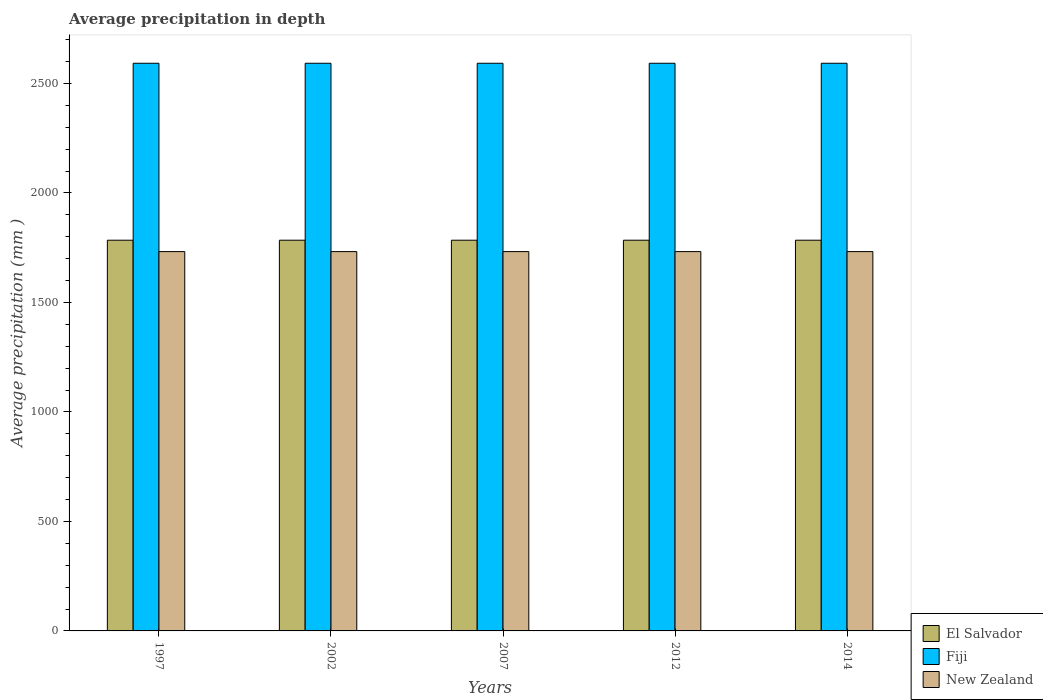How many different coloured bars are there?
Keep it short and to the point. 3. How many groups of bars are there?
Offer a terse response. 5. Are the number of bars per tick equal to the number of legend labels?
Your response must be concise. Yes. In how many cases, is the number of bars for a given year not equal to the number of legend labels?
Offer a terse response. 0. What is the average precipitation in New Zealand in 2002?
Your answer should be very brief. 1732. Across all years, what is the maximum average precipitation in El Salvador?
Offer a very short reply. 1784. Across all years, what is the minimum average precipitation in New Zealand?
Your response must be concise. 1732. What is the total average precipitation in New Zealand in the graph?
Offer a terse response. 8660. What is the difference between the average precipitation in New Zealand in 2002 and that in 2007?
Provide a succinct answer. 0. What is the difference between the average precipitation in El Salvador in 2012 and the average precipitation in Fiji in 2002?
Give a very brief answer. -808. What is the average average precipitation in El Salvador per year?
Ensure brevity in your answer.  1784. In the year 2012, what is the difference between the average precipitation in El Salvador and average precipitation in New Zealand?
Your answer should be very brief. 52. What is the ratio of the average precipitation in El Salvador in 1997 to that in 2014?
Provide a succinct answer. 1. Is the average precipitation in Fiji in 1997 less than that in 2012?
Provide a short and direct response. No. What is the difference between the highest and the second highest average precipitation in Fiji?
Make the answer very short. 0. What does the 3rd bar from the left in 2002 represents?
Provide a succinct answer. New Zealand. What does the 3rd bar from the right in 2014 represents?
Keep it short and to the point. El Salvador. Are the values on the major ticks of Y-axis written in scientific E-notation?
Ensure brevity in your answer.  No. Does the graph contain any zero values?
Make the answer very short. No. Where does the legend appear in the graph?
Provide a short and direct response. Bottom right. What is the title of the graph?
Provide a succinct answer. Average precipitation in depth. Does "Sub-Saharan Africa (all income levels)" appear as one of the legend labels in the graph?
Your answer should be compact. No. What is the label or title of the X-axis?
Provide a succinct answer. Years. What is the label or title of the Y-axis?
Give a very brief answer. Average precipitation (mm ). What is the Average precipitation (mm ) in El Salvador in 1997?
Make the answer very short. 1784. What is the Average precipitation (mm ) of Fiji in 1997?
Your answer should be very brief. 2592. What is the Average precipitation (mm ) in New Zealand in 1997?
Provide a short and direct response. 1732. What is the Average precipitation (mm ) in El Salvador in 2002?
Offer a terse response. 1784. What is the Average precipitation (mm ) of Fiji in 2002?
Offer a terse response. 2592. What is the Average precipitation (mm ) in New Zealand in 2002?
Your answer should be very brief. 1732. What is the Average precipitation (mm ) in El Salvador in 2007?
Make the answer very short. 1784. What is the Average precipitation (mm ) in Fiji in 2007?
Make the answer very short. 2592. What is the Average precipitation (mm ) of New Zealand in 2007?
Your response must be concise. 1732. What is the Average precipitation (mm ) of El Salvador in 2012?
Offer a terse response. 1784. What is the Average precipitation (mm ) in Fiji in 2012?
Your answer should be compact. 2592. What is the Average precipitation (mm ) of New Zealand in 2012?
Your response must be concise. 1732. What is the Average precipitation (mm ) in El Salvador in 2014?
Offer a very short reply. 1784. What is the Average precipitation (mm ) of Fiji in 2014?
Keep it short and to the point. 2592. What is the Average precipitation (mm ) in New Zealand in 2014?
Provide a short and direct response. 1732. Across all years, what is the maximum Average precipitation (mm ) of El Salvador?
Make the answer very short. 1784. Across all years, what is the maximum Average precipitation (mm ) in Fiji?
Offer a terse response. 2592. Across all years, what is the maximum Average precipitation (mm ) in New Zealand?
Ensure brevity in your answer.  1732. Across all years, what is the minimum Average precipitation (mm ) in El Salvador?
Ensure brevity in your answer.  1784. Across all years, what is the minimum Average precipitation (mm ) in Fiji?
Make the answer very short. 2592. Across all years, what is the minimum Average precipitation (mm ) of New Zealand?
Provide a succinct answer. 1732. What is the total Average precipitation (mm ) in El Salvador in the graph?
Keep it short and to the point. 8920. What is the total Average precipitation (mm ) in Fiji in the graph?
Your answer should be very brief. 1.30e+04. What is the total Average precipitation (mm ) of New Zealand in the graph?
Your answer should be very brief. 8660. What is the difference between the Average precipitation (mm ) in Fiji in 1997 and that in 2002?
Your answer should be very brief. 0. What is the difference between the Average precipitation (mm ) of New Zealand in 1997 and that in 2002?
Make the answer very short. 0. What is the difference between the Average precipitation (mm ) in El Salvador in 1997 and that in 2007?
Keep it short and to the point. 0. What is the difference between the Average precipitation (mm ) of El Salvador in 1997 and that in 2012?
Provide a succinct answer. 0. What is the difference between the Average precipitation (mm ) of New Zealand in 1997 and that in 2012?
Make the answer very short. 0. What is the difference between the Average precipitation (mm ) of El Salvador in 1997 and that in 2014?
Ensure brevity in your answer.  0. What is the difference between the Average precipitation (mm ) of Fiji in 1997 and that in 2014?
Give a very brief answer. 0. What is the difference between the Average precipitation (mm ) in New Zealand in 2002 and that in 2007?
Offer a very short reply. 0. What is the difference between the Average precipitation (mm ) in El Salvador in 2002 and that in 2014?
Give a very brief answer. 0. What is the difference between the Average precipitation (mm ) in New Zealand in 2002 and that in 2014?
Your answer should be very brief. 0. What is the difference between the Average precipitation (mm ) in Fiji in 2007 and that in 2012?
Provide a succinct answer. 0. What is the difference between the Average precipitation (mm ) in El Salvador in 2007 and that in 2014?
Your answer should be compact. 0. What is the difference between the Average precipitation (mm ) in Fiji in 2007 and that in 2014?
Provide a short and direct response. 0. What is the difference between the Average precipitation (mm ) in New Zealand in 2007 and that in 2014?
Offer a terse response. 0. What is the difference between the Average precipitation (mm ) in Fiji in 2012 and that in 2014?
Your answer should be very brief. 0. What is the difference between the Average precipitation (mm ) of New Zealand in 2012 and that in 2014?
Your response must be concise. 0. What is the difference between the Average precipitation (mm ) in El Salvador in 1997 and the Average precipitation (mm ) in Fiji in 2002?
Offer a very short reply. -808. What is the difference between the Average precipitation (mm ) in Fiji in 1997 and the Average precipitation (mm ) in New Zealand in 2002?
Offer a very short reply. 860. What is the difference between the Average precipitation (mm ) of El Salvador in 1997 and the Average precipitation (mm ) of Fiji in 2007?
Give a very brief answer. -808. What is the difference between the Average precipitation (mm ) in Fiji in 1997 and the Average precipitation (mm ) in New Zealand in 2007?
Your answer should be compact. 860. What is the difference between the Average precipitation (mm ) in El Salvador in 1997 and the Average precipitation (mm ) in Fiji in 2012?
Provide a succinct answer. -808. What is the difference between the Average precipitation (mm ) of Fiji in 1997 and the Average precipitation (mm ) of New Zealand in 2012?
Offer a very short reply. 860. What is the difference between the Average precipitation (mm ) in El Salvador in 1997 and the Average precipitation (mm ) in Fiji in 2014?
Offer a terse response. -808. What is the difference between the Average precipitation (mm ) in El Salvador in 1997 and the Average precipitation (mm ) in New Zealand in 2014?
Keep it short and to the point. 52. What is the difference between the Average precipitation (mm ) in Fiji in 1997 and the Average precipitation (mm ) in New Zealand in 2014?
Provide a succinct answer. 860. What is the difference between the Average precipitation (mm ) in El Salvador in 2002 and the Average precipitation (mm ) in Fiji in 2007?
Provide a short and direct response. -808. What is the difference between the Average precipitation (mm ) of Fiji in 2002 and the Average precipitation (mm ) of New Zealand in 2007?
Provide a succinct answer. 860. What is the difference between the Average precipitation (mm ) of El Salvador in 2002 and the Average precipitation (mm ) of Fiji in 2012?
Provide a short and direct response. -808. What is the difference between the Average precipitation (mm ) in El Salvador in 2002 and the Average precipitation (mm ) in New Zealand in 2012?
Provide a succinct answer. 52. What is the difference between the Average precipitation (mm ) of Fiji in 2002 and the Average precipitation (mm ) of New Zealand in 2012?
Your answer should be compact. 860. What is the difference between the Average precipitation (mm ) of El Salvador in 2002 and the Average precipitation (mm ) of Fiji in 2014?
Your answer should be very brief. -808. What is the difference between the Average precipitation (mm ) of Fiji in 2002 and the Average precipitation (mm ) of New Zealand in 2014?
Make the answer very short. 860. What is the difference between the Average precipitation (mm ) in El Salvador in 2007 and the Average precipitation (mm ) in Fiji in 2012?
Provide a short and direct response. -808. What is the difference between the Average precipitation (mm ) in El Salvador in 2007 and the Average precipitation (mm ) in New Zealand in 2012?
Keep it short and to the point. 52. What is the difference between the Average precipitation (mm ) in Fiji in 2007 and the Average precipitation (mm ) in New Zealand in 2012?
Make the answer very short. 860. What is the difference between the Average precipitation (mm ) of El Salvador in 2007 and the Average precipitation (mm ) of Fiji in 2014?
Give a very brief answer. -808. What is the difference between the Average precipitation (mm ) of Fiji in 2007 and the Average precipitation (mm ) of New Zealand in 2014?
Make the answer very short. 860. What is the difference between the Average precipitation (mm ) in El Salvador in 2012 and the Average precipitation (mm ) in Fiji in 2014?
Offer a very short reply. -808. What is the difference between the Average precipitation (mm ) of Fiji in 2012 and the Average precipitation (mm ) of New Zealand in 2014?
Give a very brief answer. 860. What is the average Average precipitation (mm ) of El Salvador per year?
Make the answer very short. 1784. What is the average Average precipitation (mm ) in Fiji per year?
Ensure brevity in your answer.  2592. What is the average Average precipitation (mm ) of New Zealand per year?
Provide a short and direct response. 1732. In the year 1997, what is the difference between the Average precipitation (mm ) of El Salvador and Average precipitation (mm ) of Fiji?
Your answer should be compact. -808. In the year 1997, what is the difference between the Average precipitation (mm ) of Fiji and Average precipitation (mm ) of New Zealand?
Your answer should be compact. 860. In the year 2002, what is the difference between the Average precipitation (mm ) of El Salvador and Average precipitation (mm ) of Fiji?
Offer a very short reply. -808. In the year 2002, what is the difference between the Average precipitation (mm ) in Fiji and Average precipitation (mm ) in New Zealand?
Your answer should be compact. 860. In the year 2007, what is the difference between the Average precipitation (mm ) of El Salvador and Average precipitation (mm ) of Fiji?
Offer a very short reply. -808. In the year 2007, what is the difference between the Average precipitation (mm ) of El Salvador and Average precipitation (mm ) of New Zealand?
Your answer should be very brief. 52. In the year 2007, what is the difference between the Average precipitation (mm ) of Fiji and Average precipitation (mm ) of New Zealand?
Your answer should be compact. 860. In the year 2012, what is the difference between the Average precipitation (mm ) of El Salvador and Average precipitation (mm ) of Fiji?
Give a very brief answer. -808. In the year 2012, what is the difference between the Average precipitation (mm ) of Fiji and Average precipitation (mm ) of New Zealand?
Keep it short and to the point. 860. In the year 2014, what is the difference between the Average precipitation (mm ) in El Salvador and Average precipitation (mm ) in Fiji?
Your answer should be compact. -808. In the year 2014, what is the difference between the Average precipitation (mm ) in El Salvador and Average precipitation (mm ) in New Zealand?
Keep it short and to the point. 52. In the year 2014, what is the difference between the Average precipitation (mm ) in Fiji and Average precipitation (mm ) in New Zealand?
Ensure brevity in your answer.  860. What is the ratio of the Average precipitation (mm ) of El Salvador in 1997 to that in 2002?
Give a very brief answer. 1. What is the ratio of the Average precipitation (mm ) in Fiji in 1997 to that in 2002?
Ensure brevity in your answer.  1. What is the ratio of the Average precipitation (mm ) of El Salvador in 1997 to that in 2007?
Offer a terse response. 1. What is the ratio of the Average precipitation (mm ) of El Salvador in 1997 to that in 2014?
Ensure brevity in your answer.  1. What is the ratio of the Average precipitation (mm ) of Fiji in 1997 to that in 2014?
Ensure brevity in your answer.  1. What is the ratio of the Average precipitation (mm ) in New Zealand in 1997 to that in 2014?
Ensure brevity in your answer.  1. What is the ratio of the Average precipitation (mm ) of El Salvador in 2002 to that in 2007?
Your answer should be compact. 1. What is the ratio of the Average precipitation (mm ) of Fiji in 2002 to that in 2007?
Keep it short and to the point. 1. What is the ratio of the Average precipitation (mm ) in New Zealand in 2002 to that in 2007?
Keep it short and to the point. 1. What is the ratio of the Average precipitation (mm ) of Fiji in 2002 to that in 2012?
Provide a succinct answer. 1. What is the ratio of the Average precipitation (mm ) in New Zealand in 2002 to that in 2012?
Keep it short and to the point. 1. What is the ratio of the Average precipitation (mm ) of El Salvador in 2002 to that in 2014?
Your answer should be compact. 1. What is the ratio of the Average precipitation (mm ) in El Salvador in 2007 to that in 2012?
Provide a short and direct response. 1. What is the ratio of the Average precipitation (mm ) of New Zealand in 2007 to that in 2012?
Provide a short and direct response. 1. What is the ratio of the Average precipitation (mm ) in Fiji in 2007 to that in 2014?
Offer a very short reply. 1. What is the ratio of the Average precipitation (mm ) in Fiji in 2012 to that in 2014?
Ensure brevity in your answer.  1. What is the ratio of the Average precipitation (mm ) in New Zealand in 2012 to that in 2014?
Provide a succinct answer. 1. What is the difference between the highest and the lowest Average precipitation (mm ) in El Salvador?
Give a very brief answer. 0. 